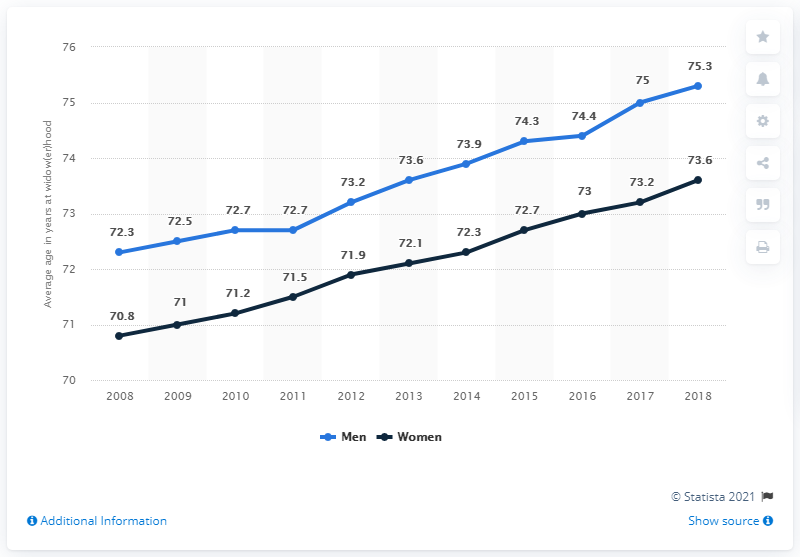Draw attention to some important aspects in this diagram. Overall, the mode of men's ages is always higher than the minimum women's age. The year with the least difference between the two data lines was 2011. 